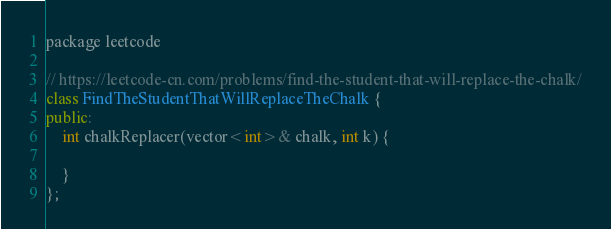<code> <loc_0><loc_0><loc_500><loc_500><_C++_>package leetcode

// https://leetcode-cn.com/problems/find-the-student-that-will-replace-the-chalk/
class FindTheStudentThatWillReplaceTheChalk {
public:
    int chalkReplacer(vector<int>& chalk, int k) {

    }
};</code> 